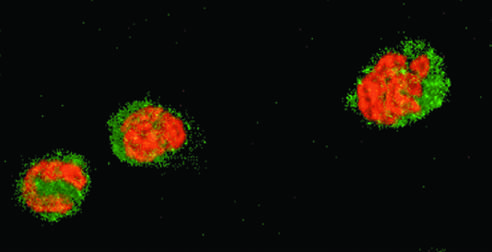what stained red and cytoplasm green?
Answer the question using a single word or phrase. Healthy neutrophils with nuclei 